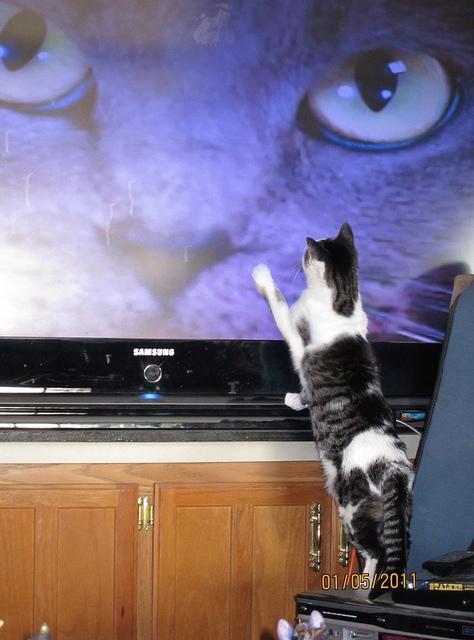How many giraffes are there?
Give a very brief answer. 0. 